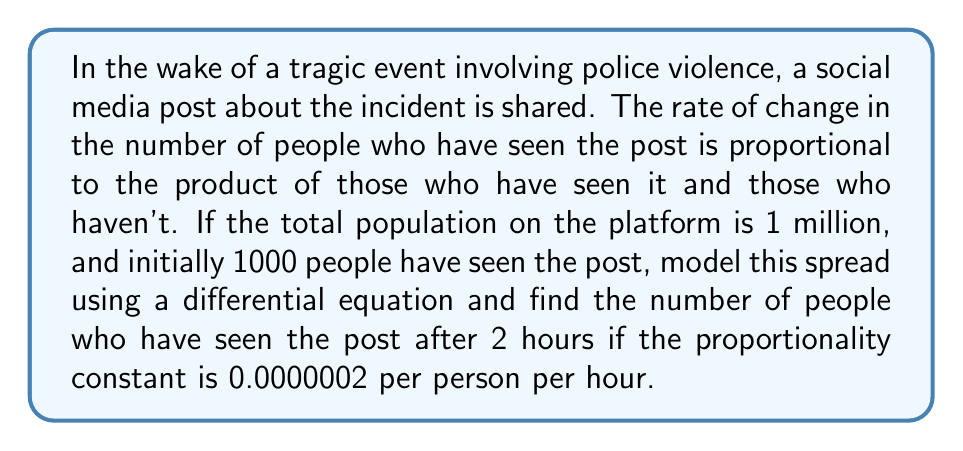Can you solve this math problem? Let's approach this step-by-step:

1) Let $P(t)$ be the number of people who have seen the post at time $t$ (in hours).

2) The total population is 1 million, so the number of people who haven't seen the post is $1,000,000 - P(t)$.

3) The rate of change is proportional to the product of these two groups:

   $$\frac{dP}{dt} = k P(t) (1,000,000 - P(t))$$

   where $k = 0.0000002$ per person per hour.

4) This is a logistic differential equation. Its solution is:

   $$P(t) = \frac{1,000,000}{1 + (\frac{1,000,000}{P_0} - 1)e^{-1,000,000kt}}$$

   where $P_0$ is the initial number of people who have seen the post.

5) We're given that $P_0 = 1000$, $k = 0.0000002$, and we want to find $P(2)$.

6) Substituting these values:

   $$P(2) = \frac{1,000,000}{1 + (\frac{1,000,000}{1000} - 1)e^{-1,000,000 \cdot 0.0000002 \cdot 2}}$$

7) Simplifying:

   $$P(2) = \frac{1,000,000}{1 + 999e^{-0.4}}$$

8) Calculating this gives us approximately 148,149 people.
Answer: 148,149 people 